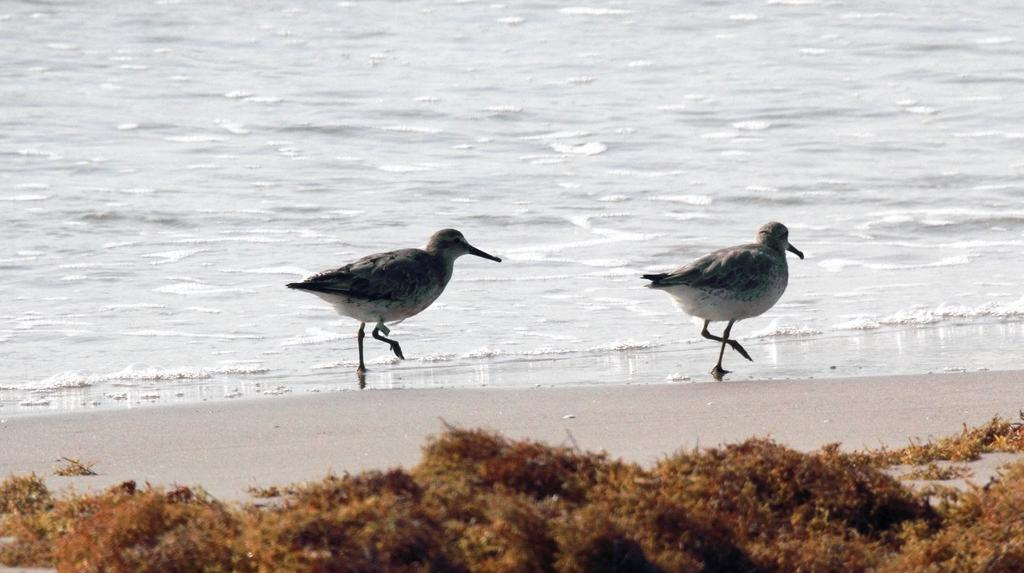How many birds can be seen in the image? There are two birds in the image. What are the birds doing in the image? The birds are walking on the seashore. What can be seen in the background of the image? There is a river in the background of the image. Are there any plants visible in the image? Yes, there are a few plants at the bottom of the image. What flavor of ice cream are the birds enjoying in the image? There is no ice cream present in the image; the birds are walking on the seashore. How many sisters do the birds have in the image? There is no information about the birds' family or siblings in the image. 